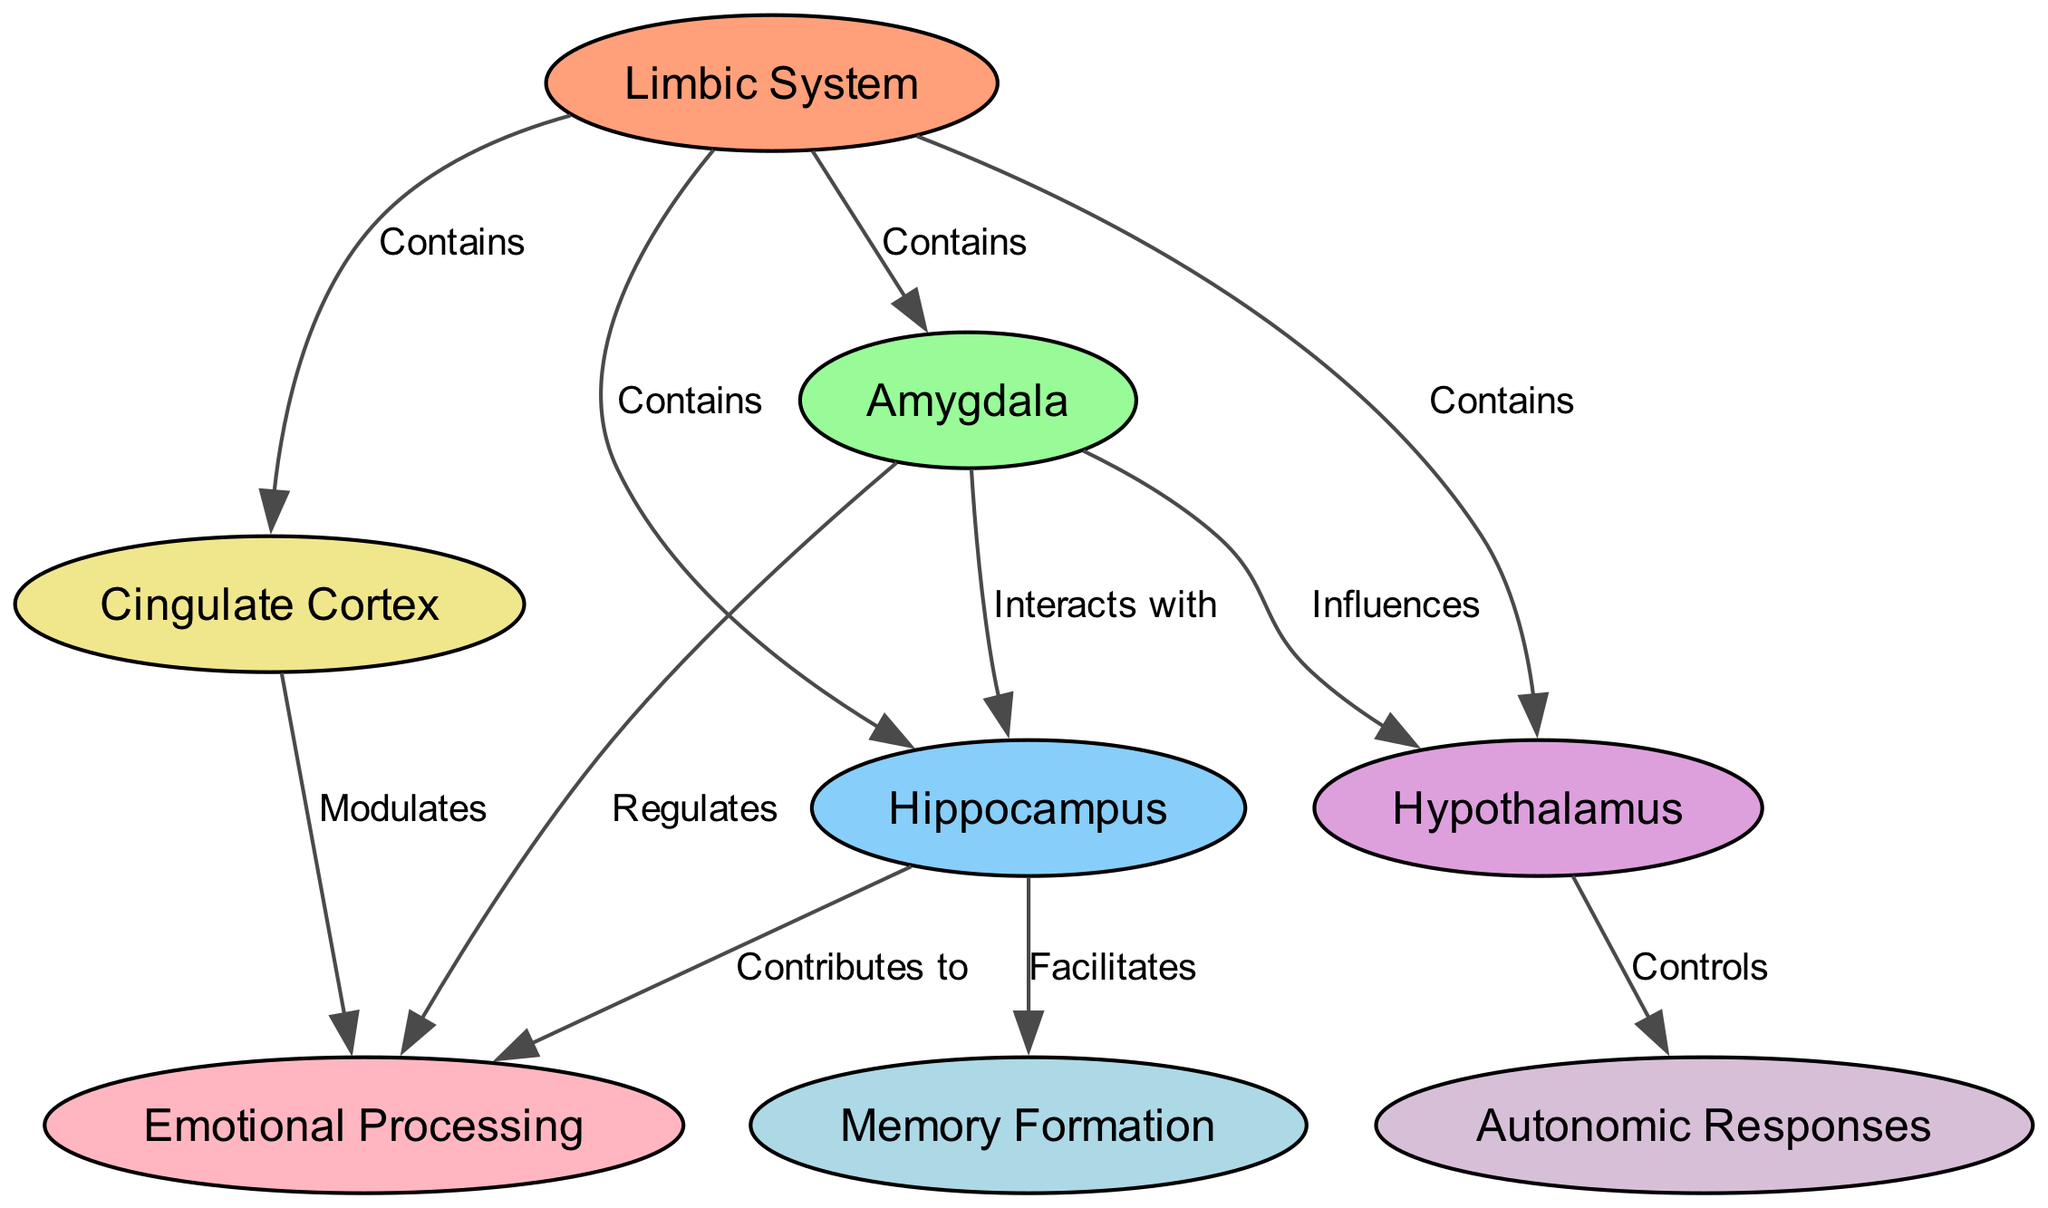What structures are contained in the limbic system? The diagram indicates that the limbic system contains four structures: amygdala, hippocampus, hypothalamus, and cingulate cortex. This is shown by the edges labeled "Contains" that connect the limbic system to these individual nodes.
Answer: amygdala, hippocampus, hypothalamus, cingulate cortex How many nodes are in the diagram? The diagram has a total of eight nodes, which are the limbic system, amygdala, hippocampus, hypothalamus, cingulate cortex, emotional processing, memory formation, and autonomic responses. By counting each node in the provided data, we arrive at this total.
Answer: 8 What does the amygdala regulate? In the diagram, the edges show that the amygdala regulates emotional processing, as indicated by the directed edge labeled "Regulates" leading from the amygdala to emotional processing.
Answer: emotional processing Which structure facilitates memory formation? The diagram shows that the hippocampus facilitates memory formation, illustrated by the edge labeled "Facilitates" connecting the hippocampus to memory formation.
Answer: hippocampus How does the hypothalamus influence autonomic responses? The diagram illustrates that the hypothalamus controls autonomic responses, as shown by the edge labeled "Controls" leading from the hypothalamus to autonomic responses. This indicates a direct connection where the hypothalamus plays a crucial role in regulating these physiological responses.
Answer: Controls What structures interact according to the diagram? According to the diagram, the structures that interact are the amygdala and hippocampus, as well as the amygdala and hypothalamus. This is conveyed through the edges labeled "Interacts with" and "Influences."
Answer: amygdala and hippocampus, amygdala and hypothalamus Which structure modulates emotional processing? The diagram shows that the cingulate cortex modulates emotional processing, as indicated by the edge labeled "Modulates" leading from the cingulate cortex to emotional processing.
Answer: cingulate cortex What contributes to emotional processing according to the hippocampus? The diagram indicates that the hippocampus contributes to emotional processing, demonstrated by the edge labeled "Contributes to" linking the hippocampus to emotional processing.
Answer: hippocampus 